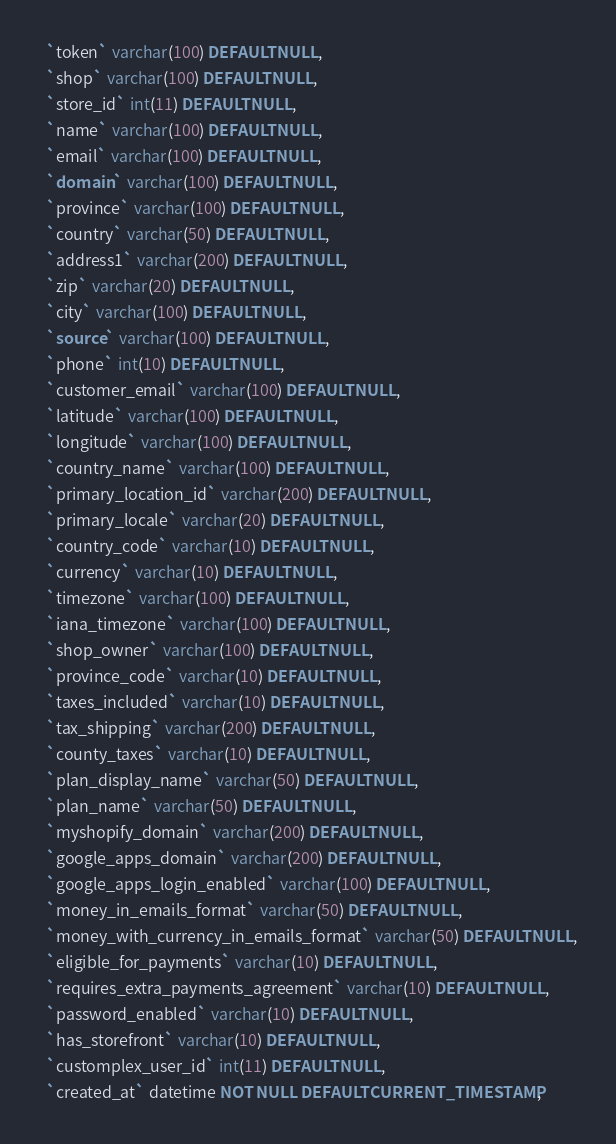Convert code to text. <code><loc_0><loc_0><loc_500><loc_500><_SQL_>  `token` varchar(100) DEFAULT NULL,
  `shop` varchar(100) DEFAULT NULL,
  `store_id` int(11) DEFAULT NULL,
  `name` varchar(100) DEFAULT NULL,
  `email` varchar(100) DEFAULT NULL,
  `domain` varchar(100) DEFAULT NULL,
  `province` varchar(100) DEFAULT NULL,
  `country` varchar(50) DEFAULT NULL,
  `address1` varchar(200) DEFAULT NULL,
  `zip` varchar(20) DEFAULT NULL,
  `city` varchar(100) DEFAULT NULL,
  `source` varchar(100) DEFAULT NULL,
  `phone` int(10) DEFAULT NULL,
  `customer_email` varchar(100) DEFAULT NULL,
  `latitude` varchar(100) DEFAULT NULL,
  `longitude` varchar(100) DEFAULT NULL,
  `country_name` varchar(100) DEFAULT NULL,
  `primary_location_id` varchar(200) DEFAULT NULL,
  `primary_locale` varchar(20) DEFAULT NULL,
  `country_code` varchar(10) DEFAULT NULL,
  `currency` varchar(10) DEFAULT NULL,
  `timezone` varchar(100) DEFAULT NULL,
  `iana_timezone` varchar(100) DEFAULT NULL,
  `shop_owner` varchar(100) DEFAULT NULL,
  `province_code` varchar(10) DEFAULT NULL,
  `taxes_included` varchar(10) DEFAULT NULL,
  `tax_shipping` varchar(200) DEFAULT NULL,
  `county_taxes` varchar(10) DEFAULT NULL,
  `plan_display_name` varchar(50) DEFAULT NULL,
  `plan_name` varchar(50) DEFAULT NULL,
  `myshopify_domain` varchar(200) DEFAULT NULL,
  `google_apps_domain` varchar(200) DEFAULT NULL,
  `google_apps_login_enabled` varchar(100) DEFAULT NULL,
  `money_in_emails_format` varchar(50) DEFAULT NULL,
  `money_with_currency_in_emails_format` varchar(50) DEFAULT NULL,
  `eligible_for_payments` varchar(10) DEFAULT NULL,
  `requires_extra_payments_agreement` varchar(10) DEFAULT NULL,
  `password_enabled` varchar(10) DEFAULT NULL,
  `has_storefront` varchar(10) DEFAULT NULL,
  `customplex_user_id` int(11) DEFAULT NULL,
  `created_at` datetime NOT NULL DEFAULT CURRENT_TIMESTAMP,</code> 